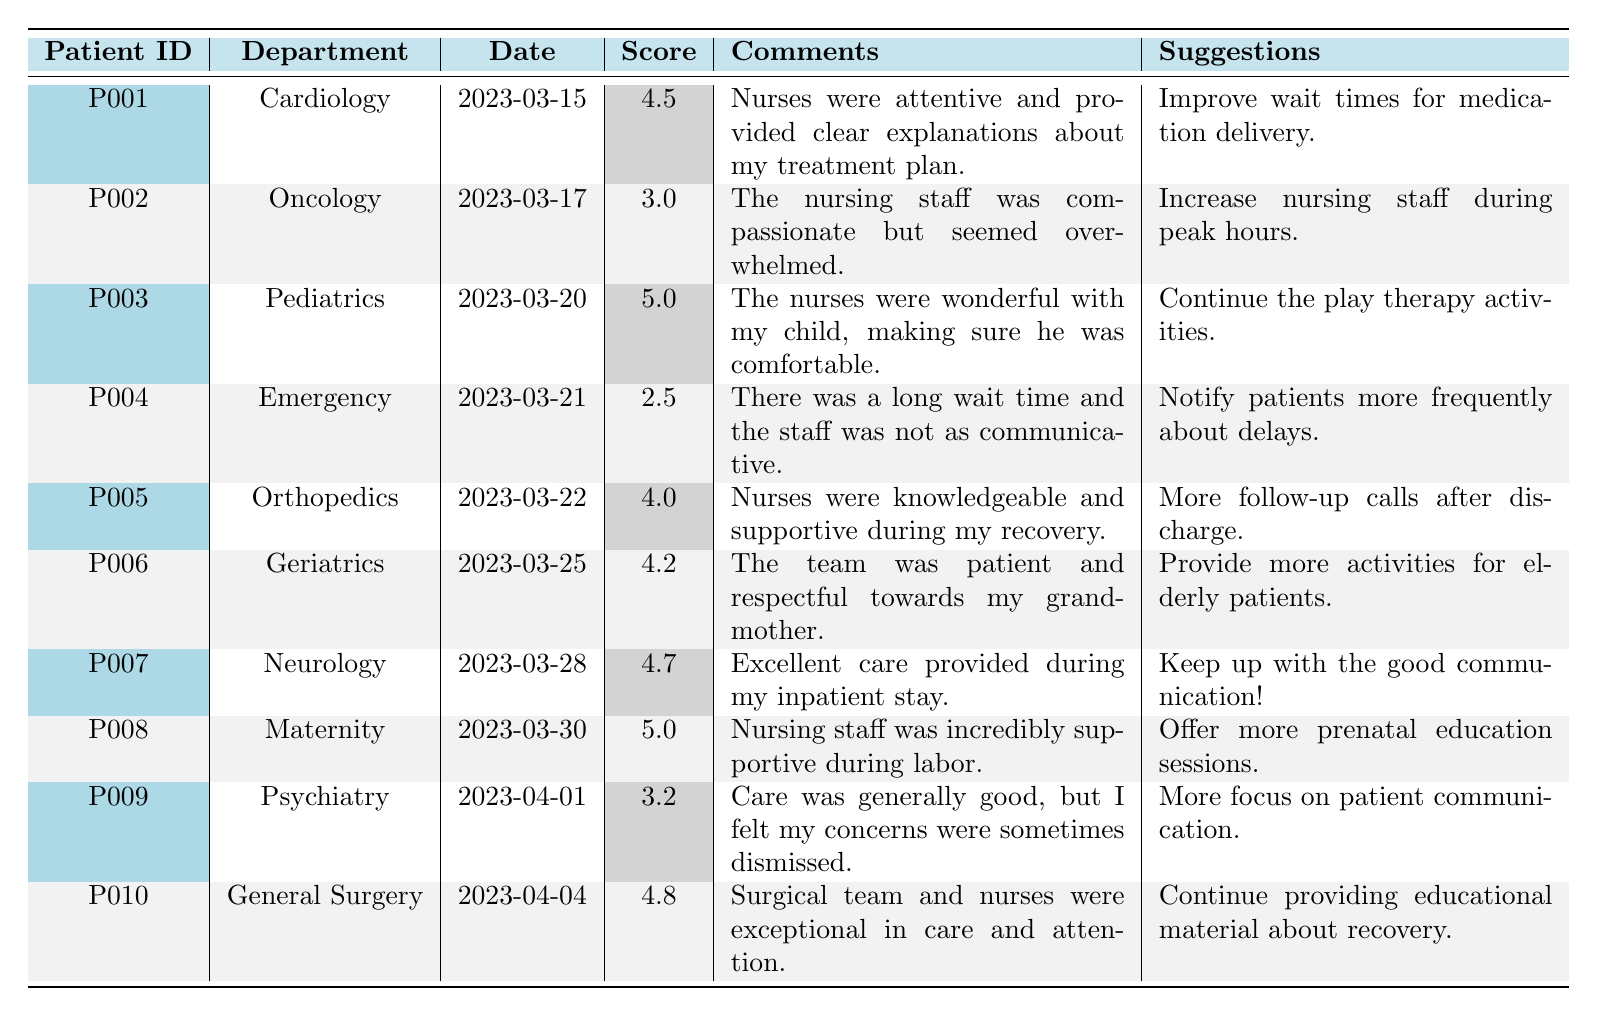What is the highest Patient Satisfaction Score in the table? The highest score is identified by scanning the "Score" column for the maximum value, which is 5.0 for patients P003 and P008.
Answer: 5.0 Which department had the lowest Patient Satisfaction Score? By reviewing the "Score" column, the lowest score of 2.5 is found in the Emergency department for patient P004.
Answer: Emergency How many patients provided feedback on nursing care with a score of 4.0 or higher? Count the scores in the table that are 4.0 or above. They are P001, P003, P005, P006, P007, P008, and P010, totaling 7 patients.
Answer: 7 What percentage of patients rated their satisfaction score above 3.5? There are 10 total patients, and those with scores above 3.5 are P001, P003, P005, P006, P007, P008, and P010, which is 7 patients. Calculate the percentage as (7/10) * 100 = 70%.
Answer: 70% Which patient suggested improved wait times for medication delivery? Reviewing the "Suggestions" column, patient P001 mentioned the need to improve wait times for medication delivery.
Answer: P001 Did any patients report feeling that their concerns were dismissed? Look for any comments that reflect this sentiment; patient P009's comment expresses that concern.
Answer: Yes What is the average Patient Satisfaction Score across all patients? Sum all the scores: (4.5 + 3.0 + 5.0 + 2.5 + 4.0 + 4.2 + 4.7 + 5.0 + 3.2 + 4.8) = 41.9, then divide by the number of patients, which is 10. The average score is 41.9 / 10 = 4.19.
Answer: 4.19 Which patients mentioned the need for better communication from staff? Check the "Comments" section and identify those patients who commented on communication; P004 and P009 both referenced issues with communication.
Answer: P004, P009 What was the feedback trend regarding nursing care in the Maternity department? Patient P008 gave a very positive review with a satisfaction score of 5.0 and commented on the support received during labor, indicating a very positive trend.
Answer: Very positive How did the patient satisfaction score for the Emergency department compare to the average score? The Emergency department's score is 2.5, which is below the average score of 4.19, indicating dissatisfaction when compared to overall patient feedback.
Answer: Below average 